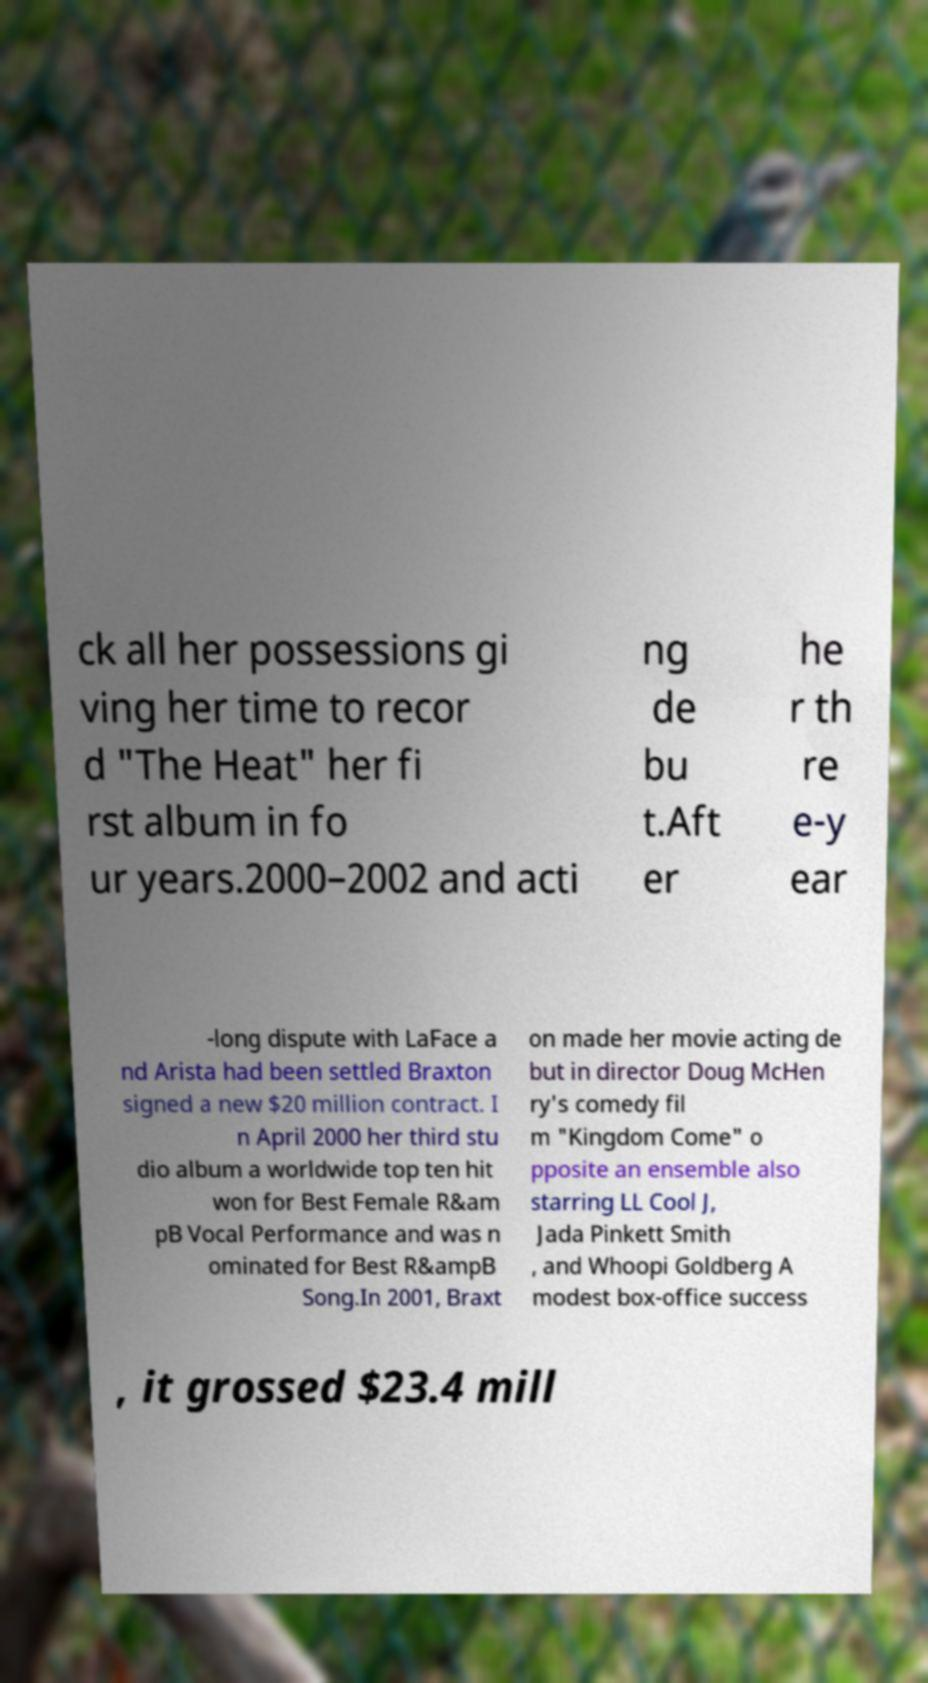I need the written content from this picture converted into text. Can you do that? ck all her possessions gi ving her time to recor d "The Heat" her fi rst album in fo ur years.2000–2002 and acti ng de bu t.Aft er he r th re e-y ear -long dispute with LaFace a nd Arista had been settled Braxton signed a new $20 million contract. I n April 2000 her third stu dio album a worldwide top ten hit won for Best Female R&am pB Vocal Performance and was n ominated for Best R&ampB Song.In 2001, Braxt on made her movie acting de but in director Doug McHen ry's comedy fil m "Kingdom Come" o pposite an ensemble also starring LL Cool J, Jada Pinkett Smith , and Whoopi Goldberg A modest box-office success , it grossed $23.4 mill 